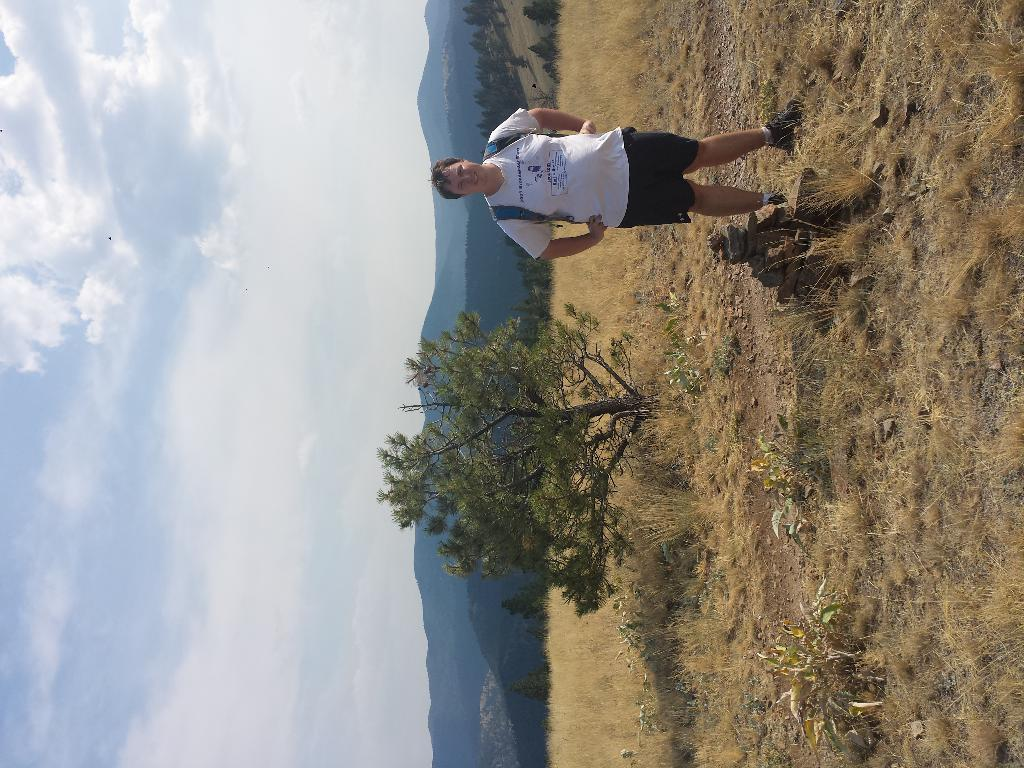Who is present in the image? There is a man in the image. What is the man wearing? The man is wearing a bag. What can be seen behind the man? There are trees visible behind the man. What other features can be seen in the background? There are hills and clouds visible in the background. What is in front of the man? There are rocks in front of the man. What type of leaf can be seen falling through the window in the image? There is no window or leaf present in the image. 